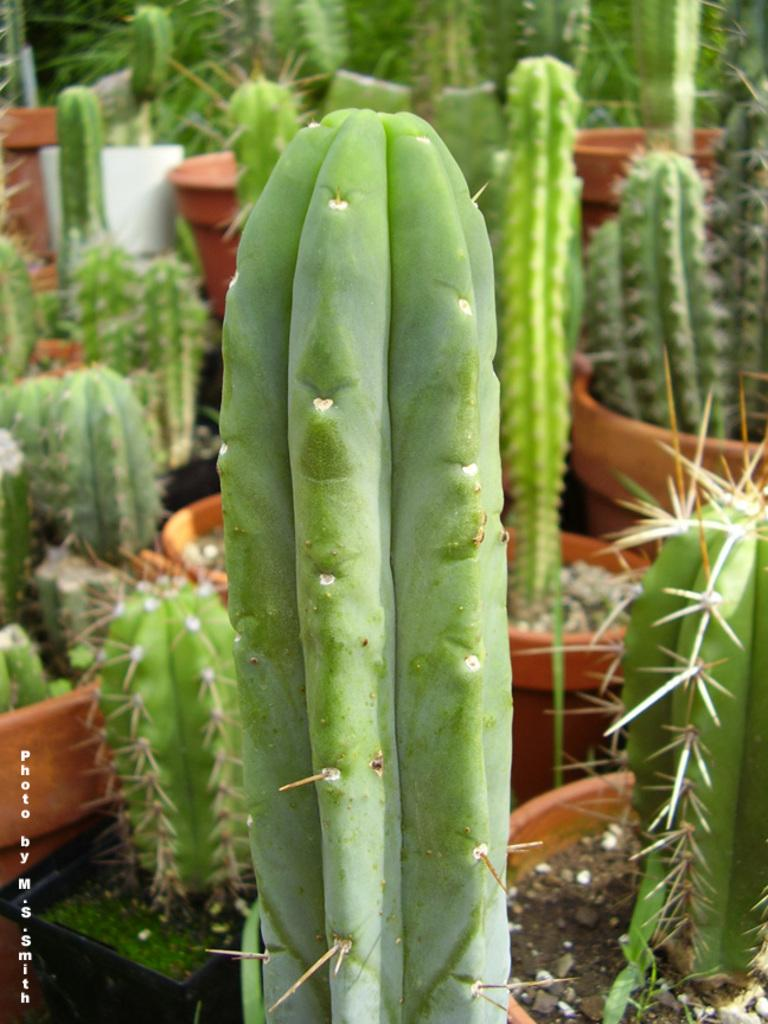What type of plants are in the image? There are cactus pot plants in the image. What feature do the cactus plants have? The cactus plants have thorns. Can you describe any other element in the image? There is a water mark on the left side of the image. What type of disease is the minister suffering from in the image? There is no minister present in the image, so it is not possible to determine if they are suffering from any disease. 